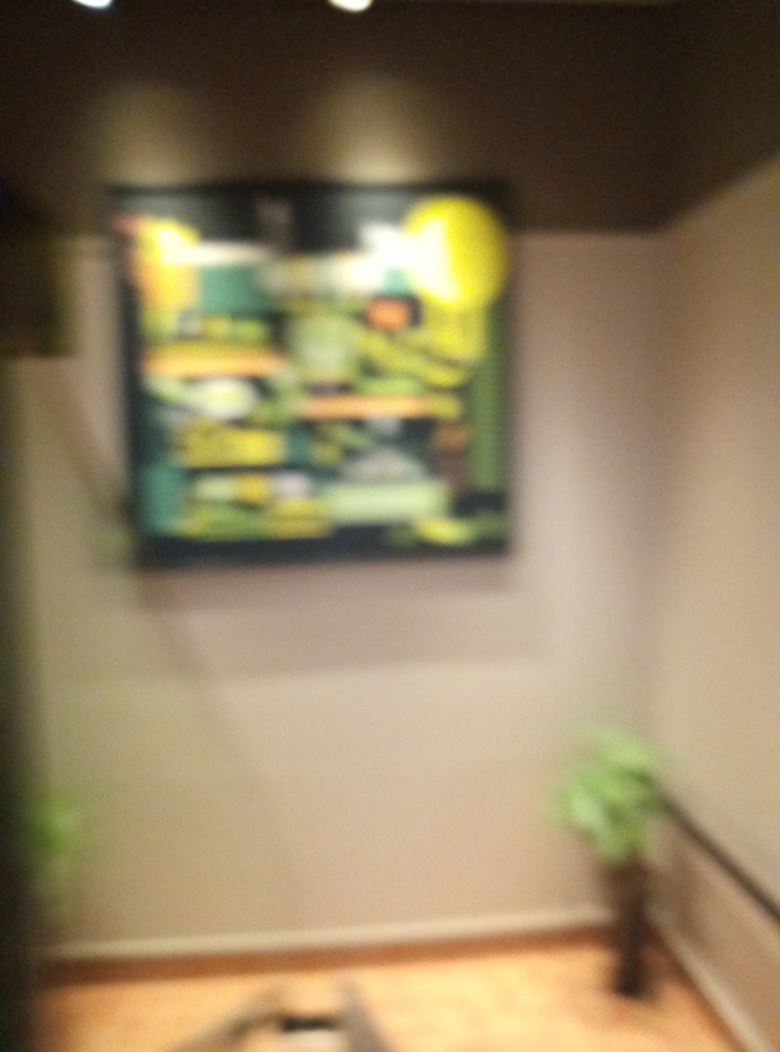Can you see details clearly in the image?
A. No
B. Yes
Answer with the option's letter from the given choices directly.
 A. 